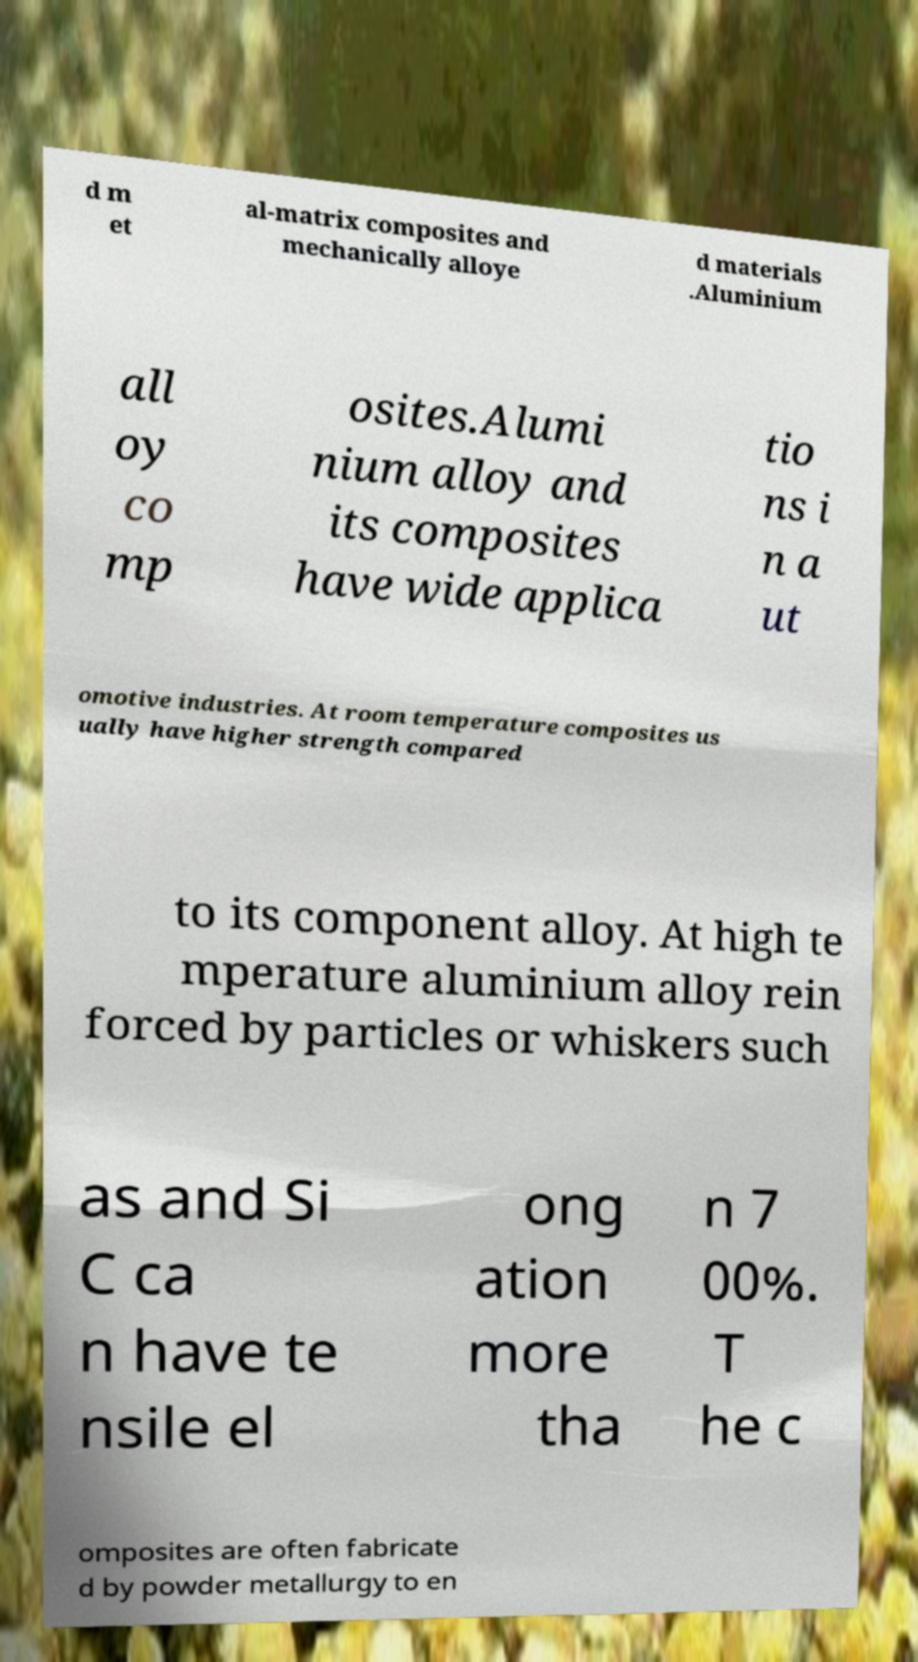Can you read and provide the text displayed in the image?This photo seems to have some interesting text. Can you extract and type it out for me? d m et al-matrix composites and mechanically alloye d materials .Aluminium all oy co mp osites.Alumi nium alloy and its composites have wide applica tio ns i n a ut omotive industries. At room temperature composites us ually have higher strength compared to its component alloy. At high te mperature aluminium alloy rein forced by particles or whiskers such as and Si C ca n have te nsile el ong ation more tha n 7 00%. T he c omposites are often fabricate d by powder metallurgy to en 